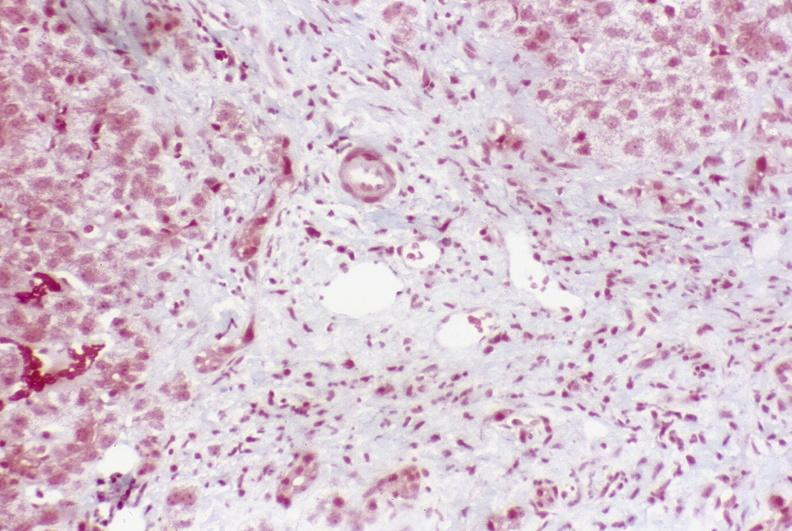does esophagus show primary sclerosing cholangitis?
Answer the question using a single word or phrase. No 